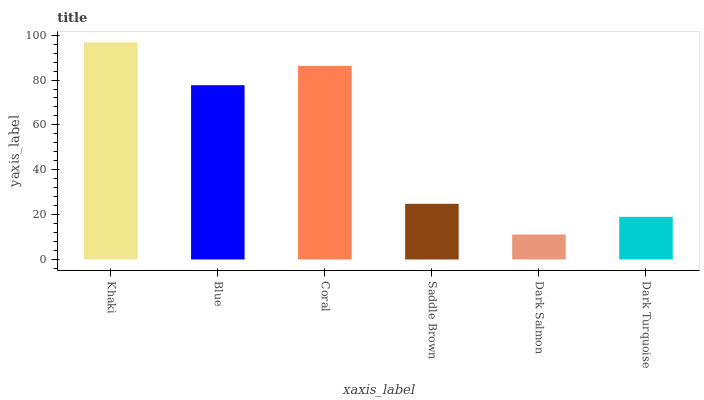Is Dark Salmon the minimum?
Answer yes or no. Yes. Is Khaki the maximum?
Answer yes or no. Yes. Is Blue the minimum?
Answer yes or no. No. Is Blue the maximum?
Answer yes or no. No. Is Khaki greater than Blue?
Answer yes or no. Yes. Is Blue less than Khaki?
Answer yes or no. Yes. Is Blue greater than Khaki?
Answer yes or no. No. Is Khaki less than Blue?
Answer yes or no. No. Is Blue the high median?
Answer yes or no. Yes. Is Saddle Brown the low median?
Answer yes or no. Yes. Is Dark Turquoise the high median?
Answer yes or no. No. Is Dark Turquoise the low median?
Answer yes or no. No. 